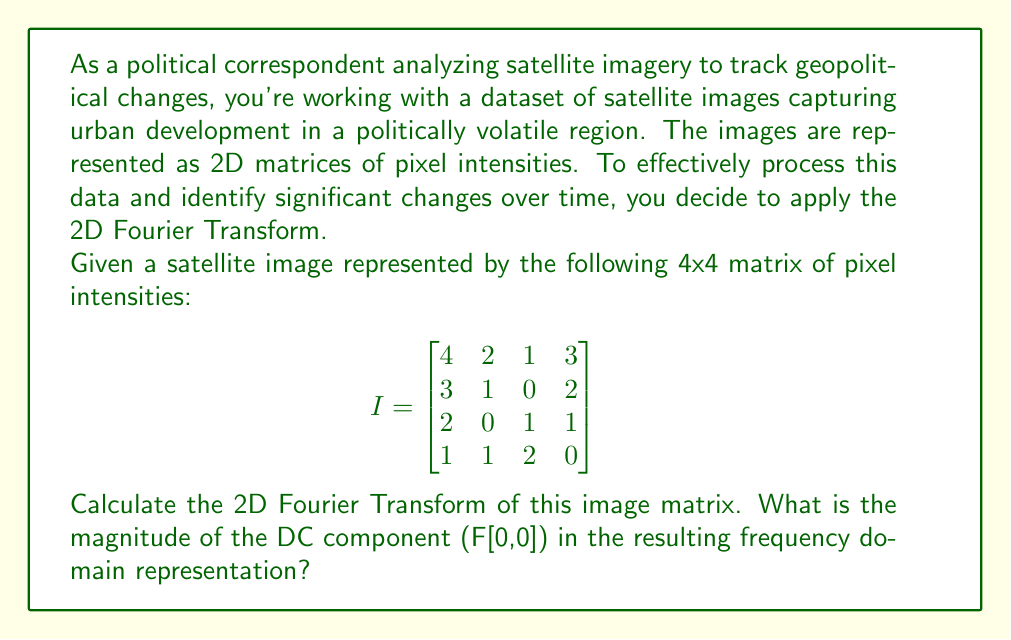Teach me how to tackle this problem. To solve this problem, we'll follow these steps:

1) The 2D Fourier Transform for a discrete image of size MxN is given by:

   $$F[k,l] = \sum_{m=0}^{M-1} \sum_{n=0}^{N-1} I[m,n] \cdot e^{-2\pi i(km/M + ln/N)}$$

   Where $I[m,n]$ is the pixel intensity at position (m,n), and $F[k,l]$ is the frequency domain representation.

2) For the DC component, $k=0$ and $l=0$, so the exponential term becomes 1:

   $$F[0,0] = \sum_{m=0}^{M-1} \sum_{n=0}^{N-1} I[m,n]$$

3) This means the DC component is simply the sum of all pixel intensities in the image.

4) Let's sum all the elements in the given matrix:

   $4 + 2 + 1 + 3 + 3 + 1 + 0 + 2 + 2 + 0 + 1 + 1 + 1 + 1 + 2 + 0 = 24$

5) The magnitude of a real number is its absolute value. Since 24 is already positive, its magnitude is 24.

Therefore, the magnitude of the DC component (F[0,0]) in the frequency domain representation is 24.
Answer: 24 